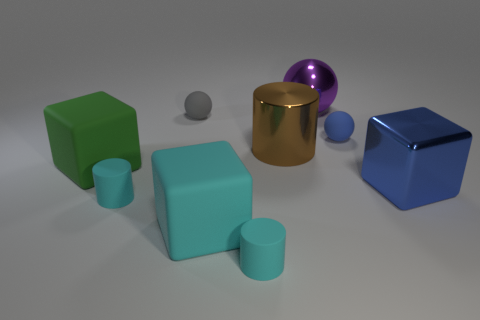What could be inferred about the materials of the objects? From the image, the metallic sheen on the cylinder and sphere suggests they're made of a polished metal. The cubes and the cylinder-pair look matte and could be made of a material like plastic or painted wood. 